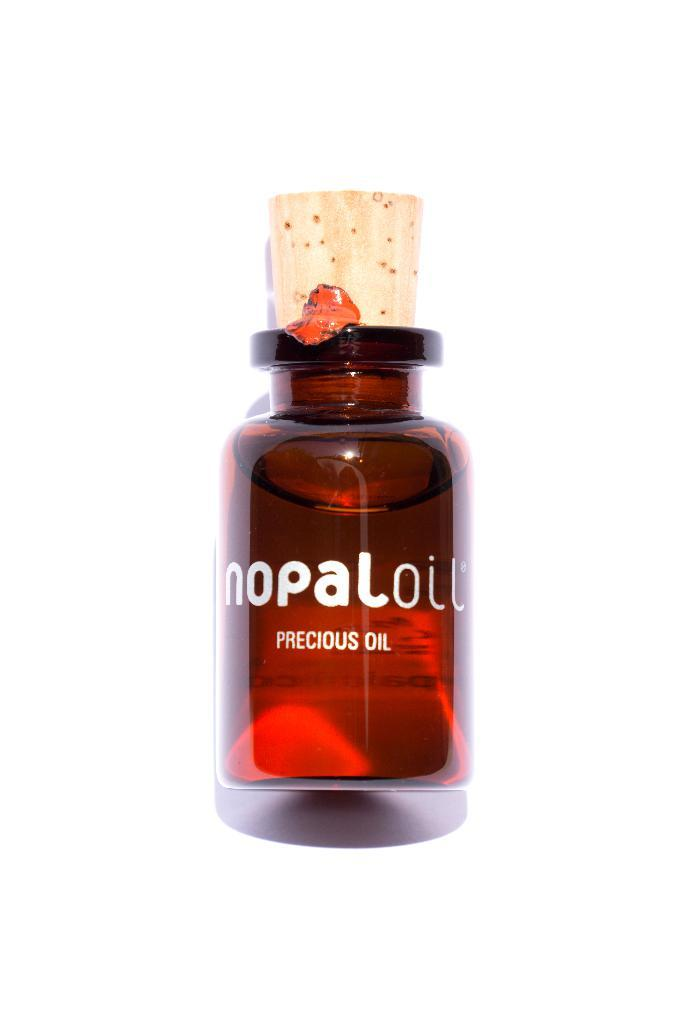<image>
Describe the image concisely. A small amber colored bottle of Nopal precious oil with cork stopper. 